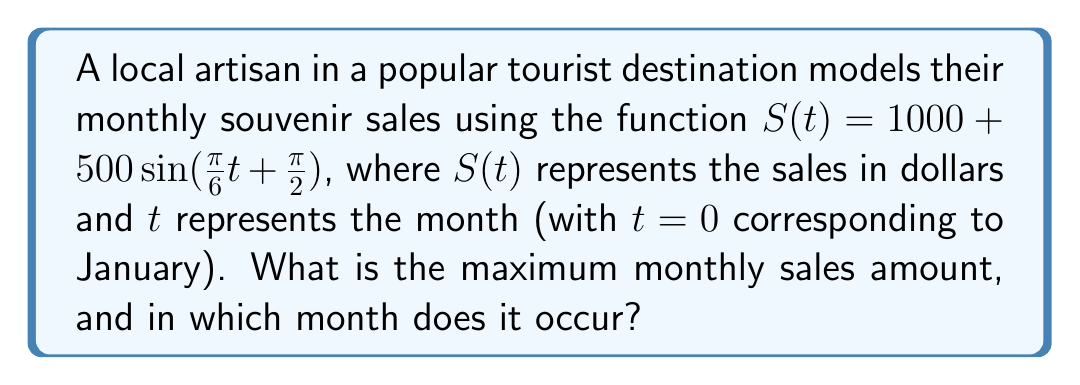What is the answer to this math problem? To solve this problem, we'll follow these steps:

1) The general form of a sine function is $A\sin(B(t-C)) + D$, where:
   $A$ is the amplitude
   $B$ is the frequency
   $C$ is the phase shift
   $D$ is the vertical shift

2) In our function $S(t) = 1000 + 500\sin(\frac{\pi}{6}t + \frac{\pi}{2})$:
   $A = 500$
   $B = \frac{\pi}{6}$
   $D = 1000$

3) The maximum value of a sine function occurs when $\sin(\theta) = 1$, which happens when $\theta = \frac{\pi}{2}$ (or 90°).

4) The maximum sales will be:
   $S_{max} = D + A = 1000 + 500 = 1500$

5) To find when this maximum occurs, we solve:
   $\frac{\pi}{6}t + \frac{\pi}{2} = \frac{\pi}{2}$

6) Simplifying:
   $\frac{\pi}{6}t = 0$
   $t = 0$

7) $t = 0$ corresponds to January. However, due to the $\frac{\pi}{2}$ phase shift in the original function, the maximum actually occurs 3 months later (as $\frac{\pi}{2}$ is a quarter of a full $2\pi$ cycle).

8) Therefore, the maximum sales occur in April (the 4th month).
Answer: $1500 in April 